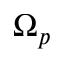Convert formula to latex. <formula><loc_0><loc_0><loc_500><loc_500>\Omega _ { p }</formula> 